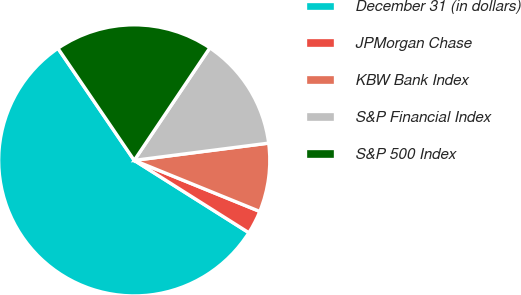<chart> <loc_0><loc_0><loc_500><loc_500><pie_chart><fcel>December 31 (in dollars)<fcel>JPMorgan Chase<fcel>KBW Bank Index<fcel>S&P Financial Index<fcel>S&P 500 Index<nl><fcel>56.52%<fcel>2.81%<fcel>8.18%<fcel>13.55%<fcel>18.93%<nl></chart> 